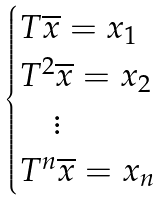Convert formula to latex. <formula><loc_0><loc_0><loc_500><loc_500>\begin{cases} T \overline { x } = x _ { 1 } \\ T ^ { 2 } \overline { x } = x _ { 2 } \\ \quad \vdots \\ T ^ { n } \overline { x } = x _ { n } \end{cases}</formula> 